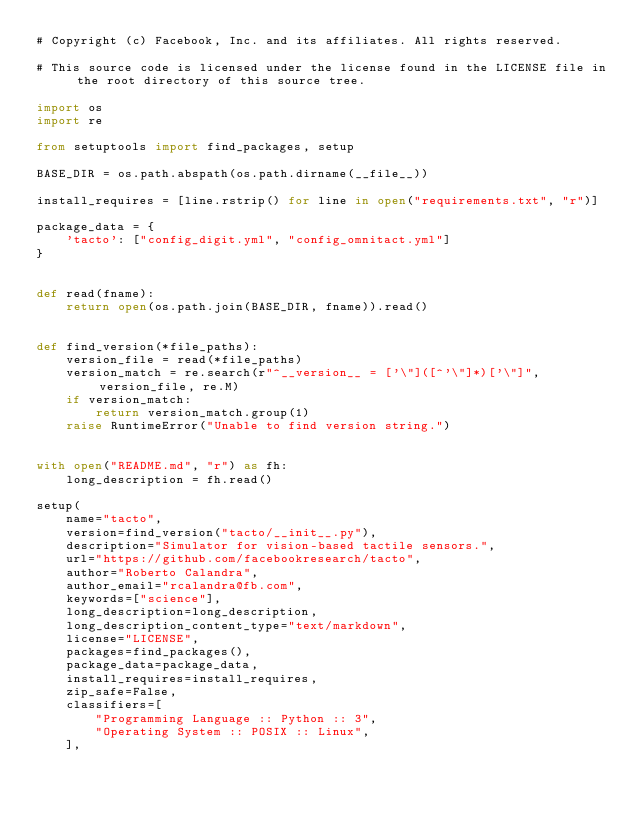Convert code to text. <code><loc_0><loc_0><loc_500><loc_500><_Python_># Copyright (c) Facebook, Inc. and its affiliates. All rights reserved.

# This source code is licensed under the license found in the LICENSE file in the root directory of this source tree.

import os
import re

from setuptools import find_packages, setup

BASE_DIR = os.path.abspath(os.path.dirname(__file__))

install_requires = [line.rstrip() for line in open("requirements.txt", "r")]

package_data = {
    'tacto': ["config_digit.yml", "config_omnitact.yml"]
}


def read(fname):
    return open(os.path.join(BASE_DIR, fname)).read()


def find_version(*file_paths):
    version_file = read(*file_paths)
    version_match = re.search(r"^__version__ = ['\"]([^'\"]*)['\"]", version_file, re.M)
    if version_match:
        return version_match.group(1)
    raise RuntimeError("Unable to find version string.")


with open("README.md", "r") as fh:
    long_description = fh.read()

setup(
    name="tacto",
    version=find_version("tacto/__init__.py"),
    description="Simulator for vision-based tactile sensors.",
    url="https://github.com/facebookresearch/tacto",
    author="Roberto Calandra",
    author_email="rcalandra@fb.com",
    keywords=["science"],
    long_description=long_description,
    long_description_content_type="text/markdown",
    license="LICENSE",
    packages=find_packages(),
    package_data=package_data,
    install_requires=install_requires,
    zip_safe=False,
    classifiers=[
        "Programming Language :: Python :: 3",
        "Operating System :: POSIX :: Linux",
    ],</code> 